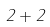<formula> <loc_0><loc_0><loc_500><loc_500>2 + 2</formula> 